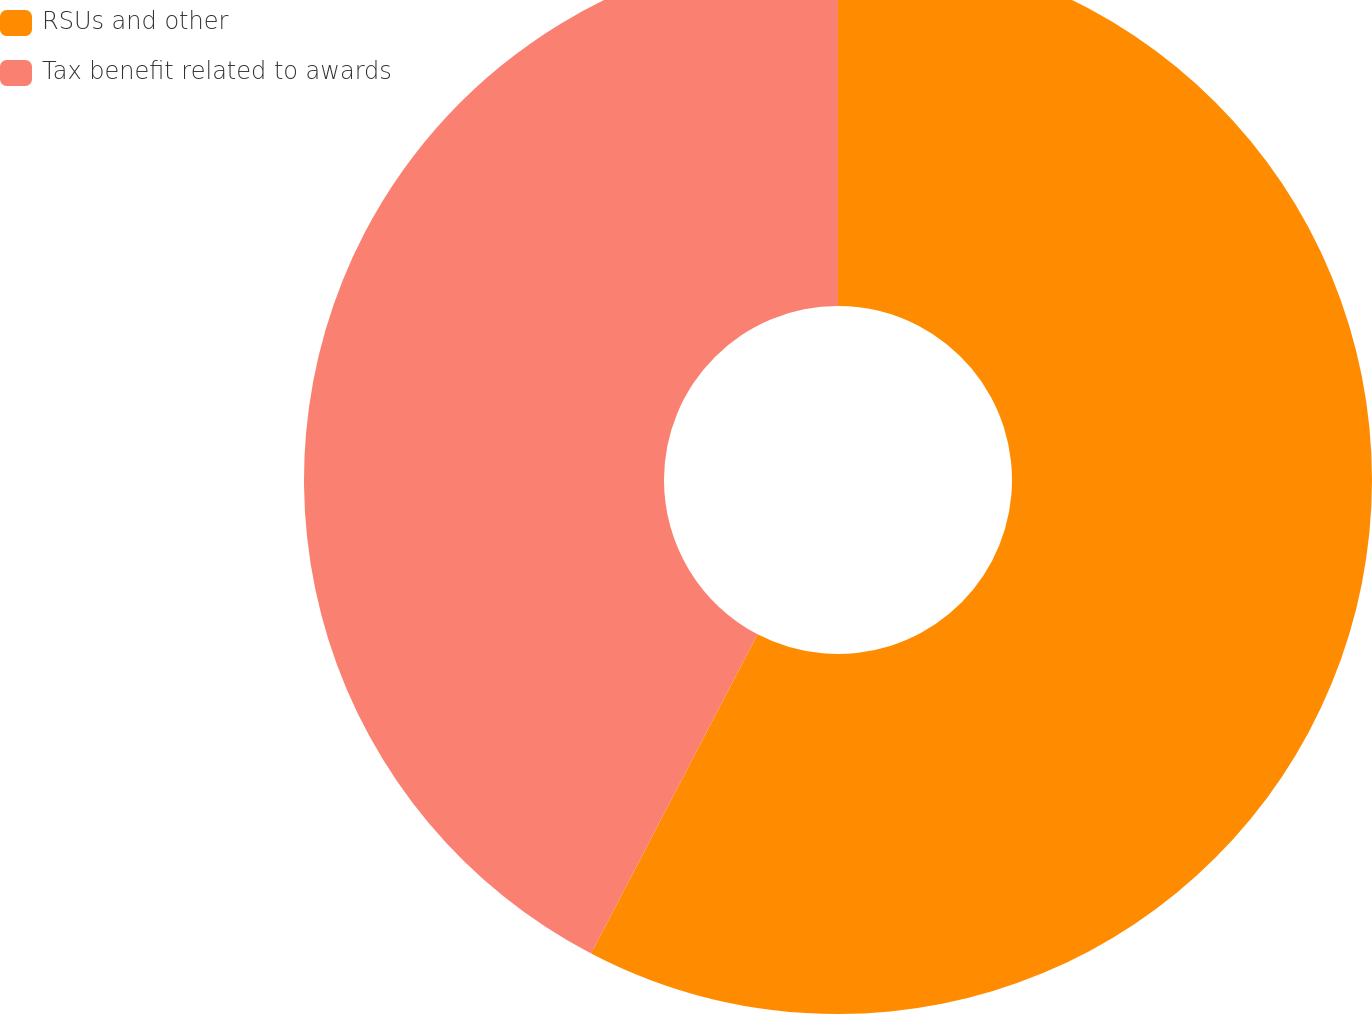Convert chart. <chart><loc_0><loc_0><loc_500><loc_500><pie_chart><fcel>RSUs and other<fcel>Tax benefit related to awards<nl><fcel>57.65%<fcel>42.35%<nl></chart> 